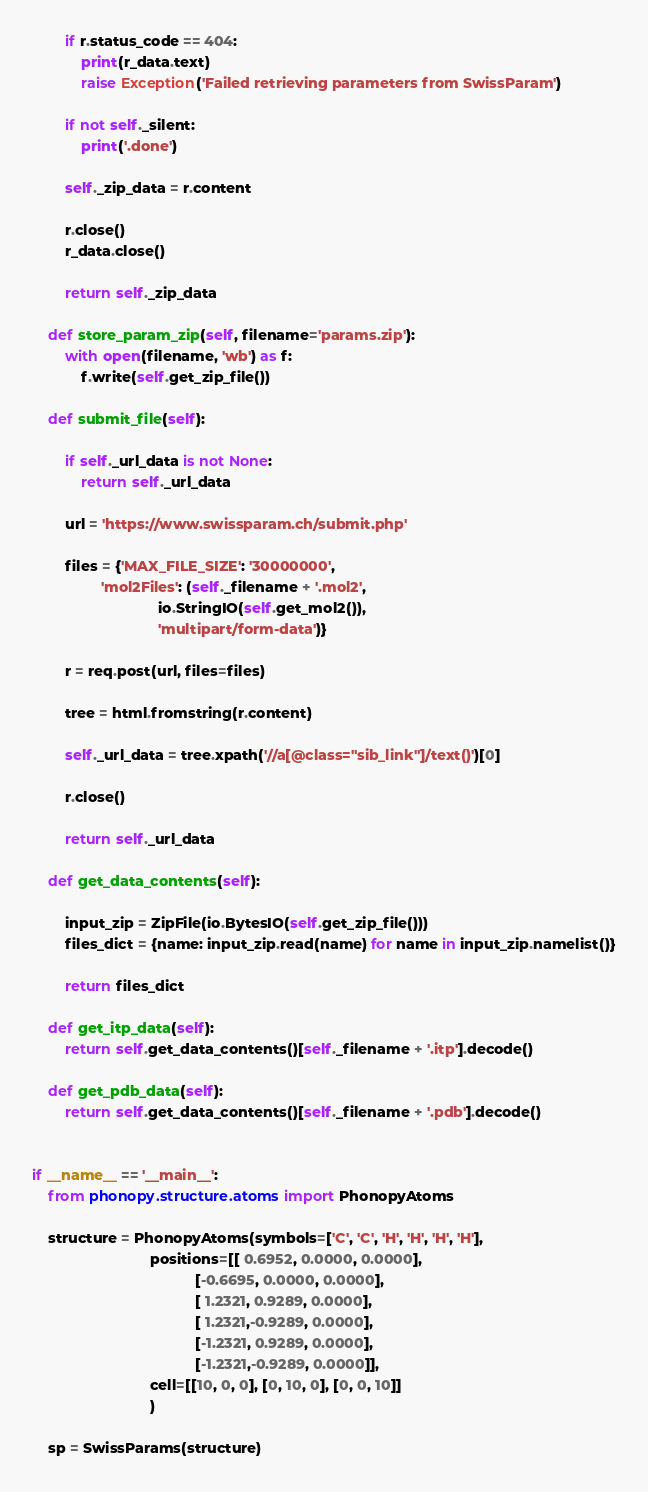<code> <loc_0><loc_0><loc_500><loc_500><_Python_>        if r.status_code == 404:
            print(r_data.text)
            raise Exception('Failed retrieving parameters from SwissParam')

        if not self._silent:
            print('.done')

        self._zip_data = r.content

        r.close()
        r_data.close()

        return self._zip_data

    def store_param_zip(self, filename='params.zip'):
        with open(filename, 'wb') as f:
            f.write(self.get_zip_file())

    def submit_file(self):

        if self._url_data is not None:
            return self._url_data

        url = 'https://www.swissparam.ch/submit.php'

        files = {'MAX_FILE_SIZE': '30000000',
                 'mol2Files': (self._filename + '.mol2',
                               io.StringIO(self.get_mol2()),
                               'multipart/form-data')}

        r = req.post(url, files=files)

        tree = html.fromstring(r.content)

        self._url_data = tree.xpath('//a[@class="sib_link"]/text()')[0]

        r.close()

        return self._url_data

    def get_data_contents(self):

        input_zip = ZipFile(io.BytesIO(self.get_zip_file()))
        files_dict = {name: input_zip.read(name) for name in input_zip.namelist()}

        return files_dict

    def get_itp_data(self):
        return self.get_data_contents()[self._filename + '.itp'].decode()

    def get_pdb_data(self):
        return self.get_data_contents()[self._filename + '.pdb'].decode()


if __name__ == '__main__':
    from phonopy.structure.atoms import PhonopyAtoms

    structure = PhonopyAtoms(symbols=['C', 'C', 'H', 'H', 'H', 'H'],
                             positions=[[ 0.6952, 0.0000, 0.0000],
                                        [-0.6695, 0.0000, 0.0000],
                                        [ 1.2321, 0.9289, 0.0000],
                                        [ 1.2321,-0.9289, 0.0000],
                                        [-1.2321, 0.9289, 0.0000],
                                        [-1.2321,-0.9289, 0.0000]],
                             cell=[[10, 0, 0], [0, 10, 0], [0, 0, 10]]
                             )

    sp = SwissParams(structure)

</code> 